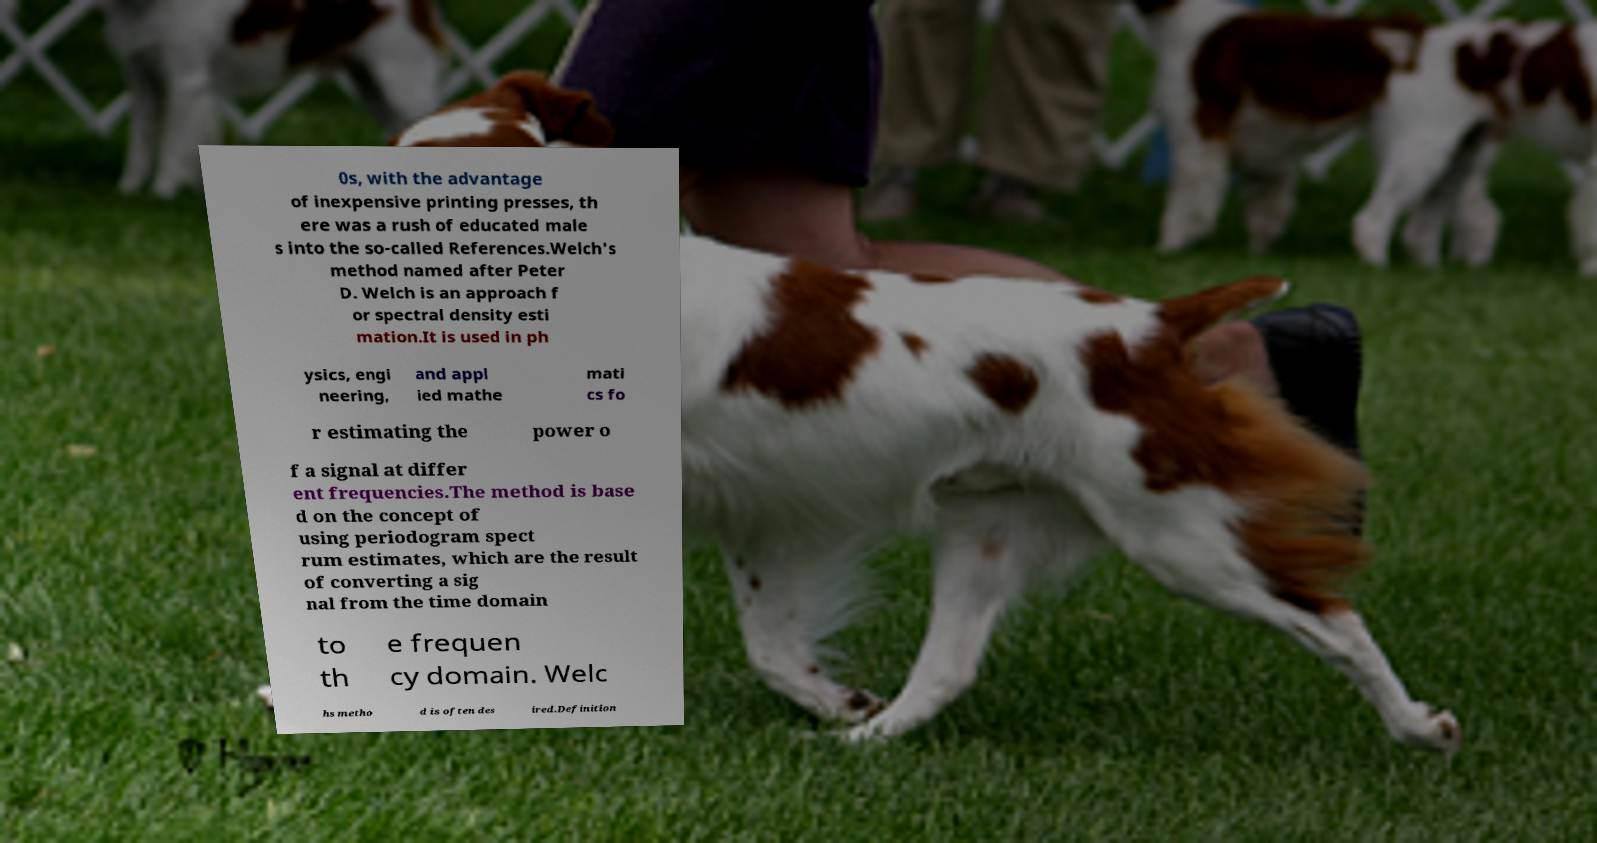There's text embedded in this image that I need extracted. Can you transcribe it verbatim? 0s, with the advantage of inexpensive printing presses, th ere was a rush of educated male s into the so-called References.Welch's method named after Peter D. Welch is an approach f or spectral density esti mation.It is used in ph ysics, engi neering, and appl ied mathe mati cs fo r estimating the power o f a signal at differ ent frequencies.The method is base d on the concept of using periodogram spect rum estimates, which are the result of converting a sig nal from the time domain to th e frequen cy domain. Welc hs metho d is often des ired.Definition 